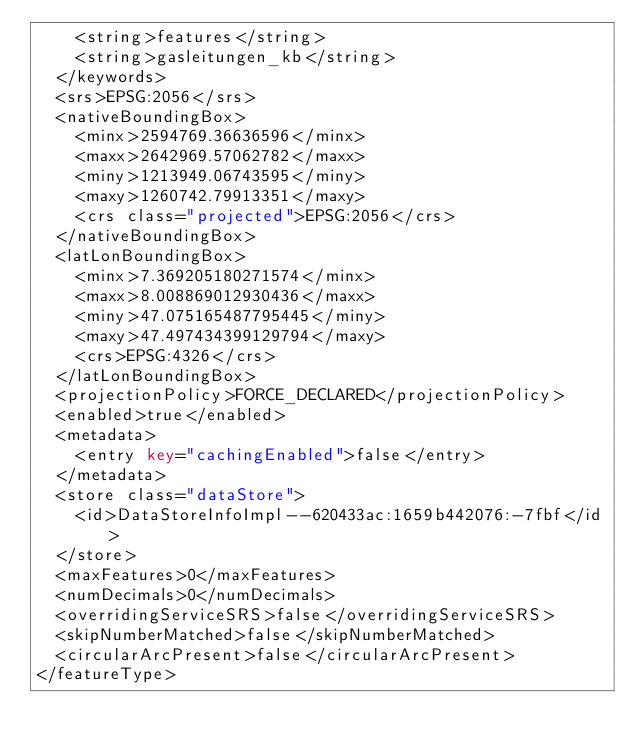<code> <loc_0><loc_0><loc_500><loc_500><_XML_>    <string>features</string>
    <string>gasleitungen_kb</string>
  </keywords>
  <srs>EPSG:2056</srs>
  <nativeBoundingBox>
    <minx>2594769.36636596</minx>
    <maxx>2642969.57062782</maxx>
    <miny>1213949.06743595</miny>
    <maxy>1260742.79913351</maxy>
    <crs class="projected">EPSG:2056</crs>
  </nativeBoundingBox>
  <latLonBoundingBox>
    <minx>7.369205180271574</minx>
    <maxx>8.008869012930436</maxx>
    <miny>47.075165487795445</miny>
    <maxy>47.497434399129794</maxy>
    <crs>EPSG:4326</crs>
  </latLonBoundingBox>
  <projectionPolicy>FORCE_DECLARED</projectionPolicy>
  <enabled>true</enabled>
  <metadata>
    <entry key="cachingEnabled">false</entry>
  </metadata>
  <store class="dataStore">
    <id>DataStoreInfoImpl--620433ac:1659b442076:-7fbf</id>
  </store>
  <maxFeatures>0</maxFeatures>
  <numDecimals>0</numDecimals>
  <overridingServiceSRS>false</overridingServiceSRS>
  <skipNumberMatched>false</skipNumberMatched>
  <circularArcPresent>false</circularArcPresent>
</featureType></code> 